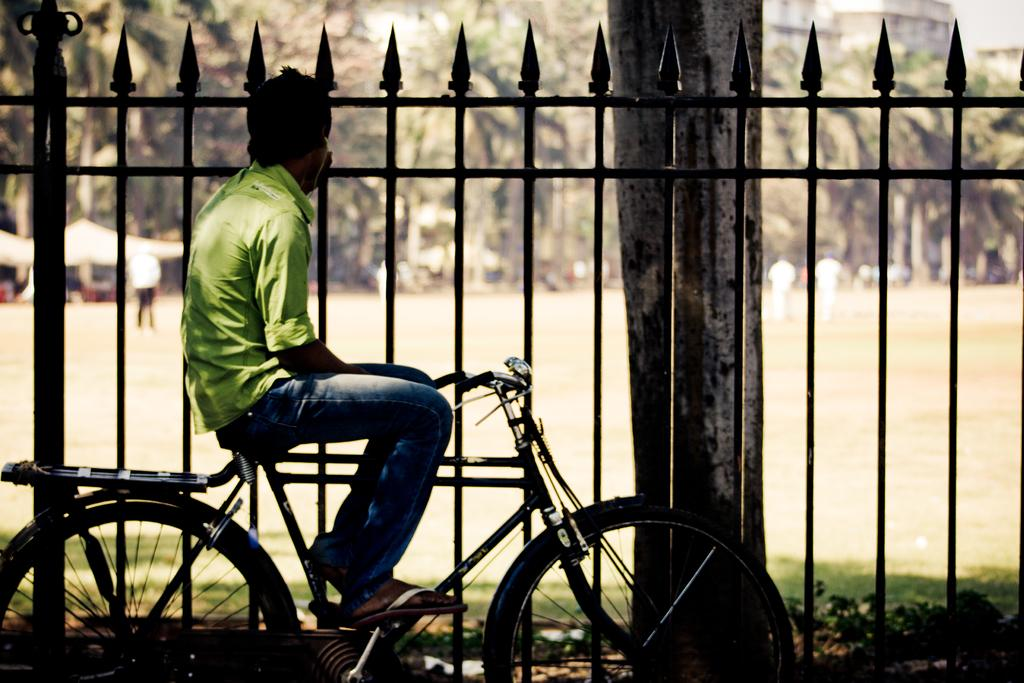What can be seen in the background of the image? There are trees and tents in the background of the image. What are the people in the image doing? There are persons standing on the ground in the image. What object is present in the image that might be used for cooking? There is a grill fence in the image. What is the man in the image doing? The man is sitting on a bicycle in the image. How many dimes are scattered on the ground in the image? There are no dimes present in the image; the focus is on the trees, tents, persons, grill fence, and man on a bicycle. 